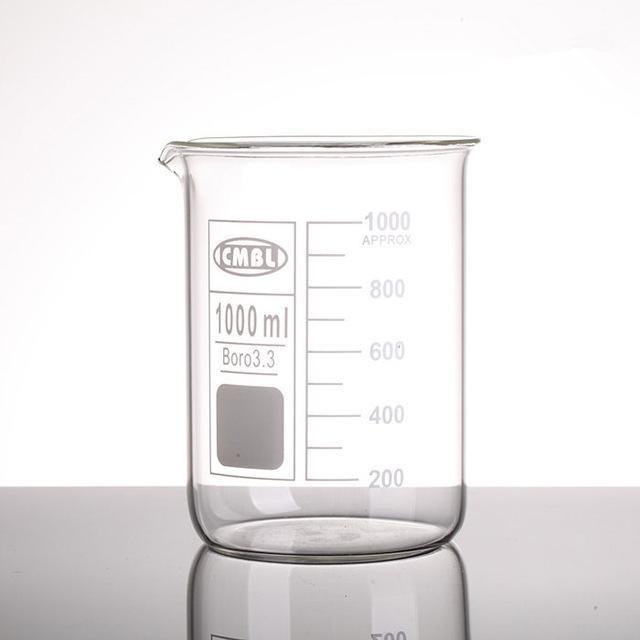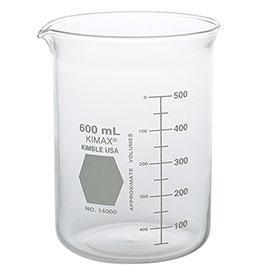The first image is the image on the left, the second image is the image on the right. Assess this claim about the two images: "There are two beakers facing left with one hexagon and one square printed on the beaker.". Correct or not? Answer yes or no. Yes. The first image is the image on the left, the second image is the image on the right. Evaluate the accuracy of this statement regarding the images: "One beaker has a gray hexagon shape next to its volume line, and the other beaker has a square shape.". Is it true? Answer yes or no. Yes. 